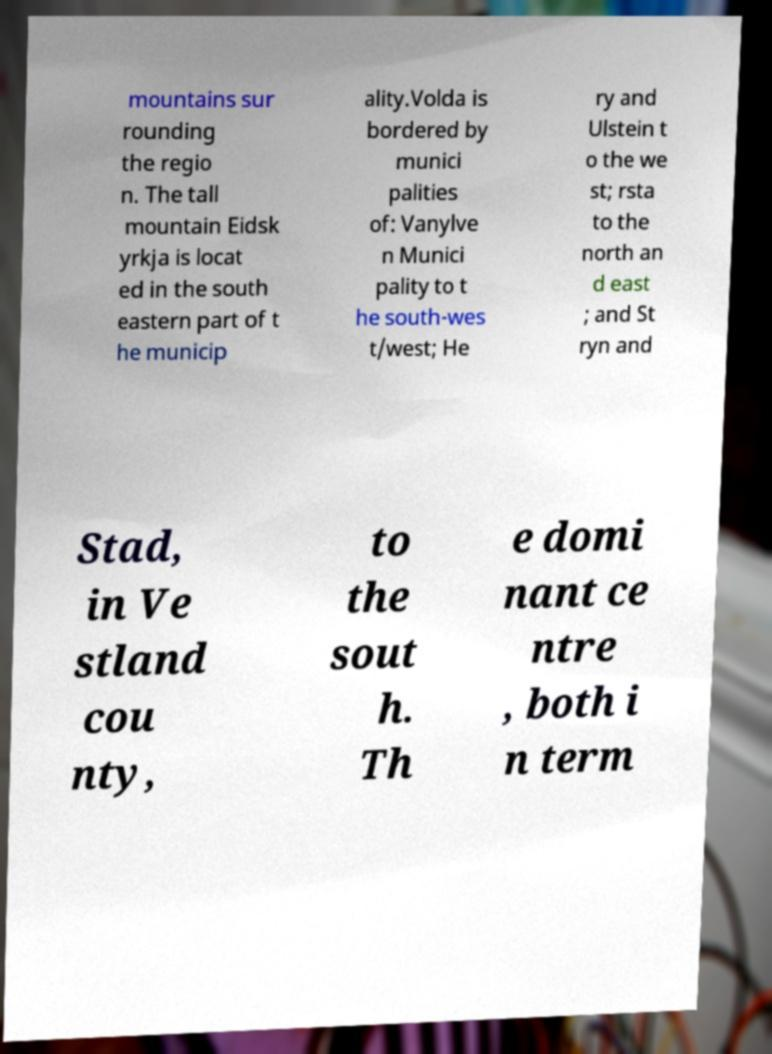For documentation purposes, I need the text within this image transcribed. Could you provide that? mountains sur rounding the regio n. The tall mountain Eidsk yrkja is locat ed in the south eastern part of t he municip ality.Volda is bordered by munici palities of: Vanylve n Munici pality to t he south-wes t/west; He ry and Ulstein t o the we st; rsta to the north an d east ; and St ryn and Stad, in Ve stland cou nty, to the sout h. Th e domi nant ce ntre , both i n term 